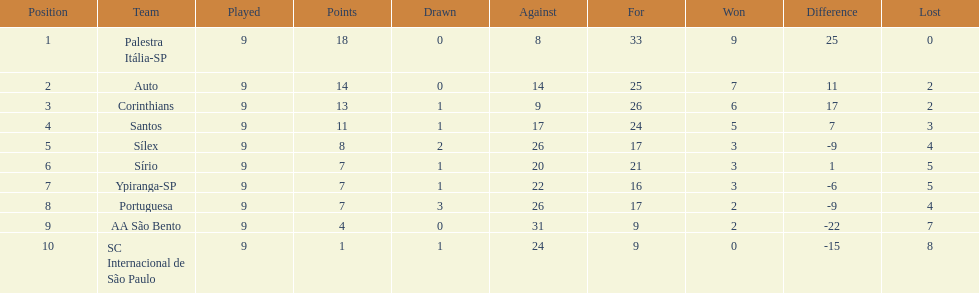In 1926 brazilian football, how many teams scored above 10 points in the season? 4. 